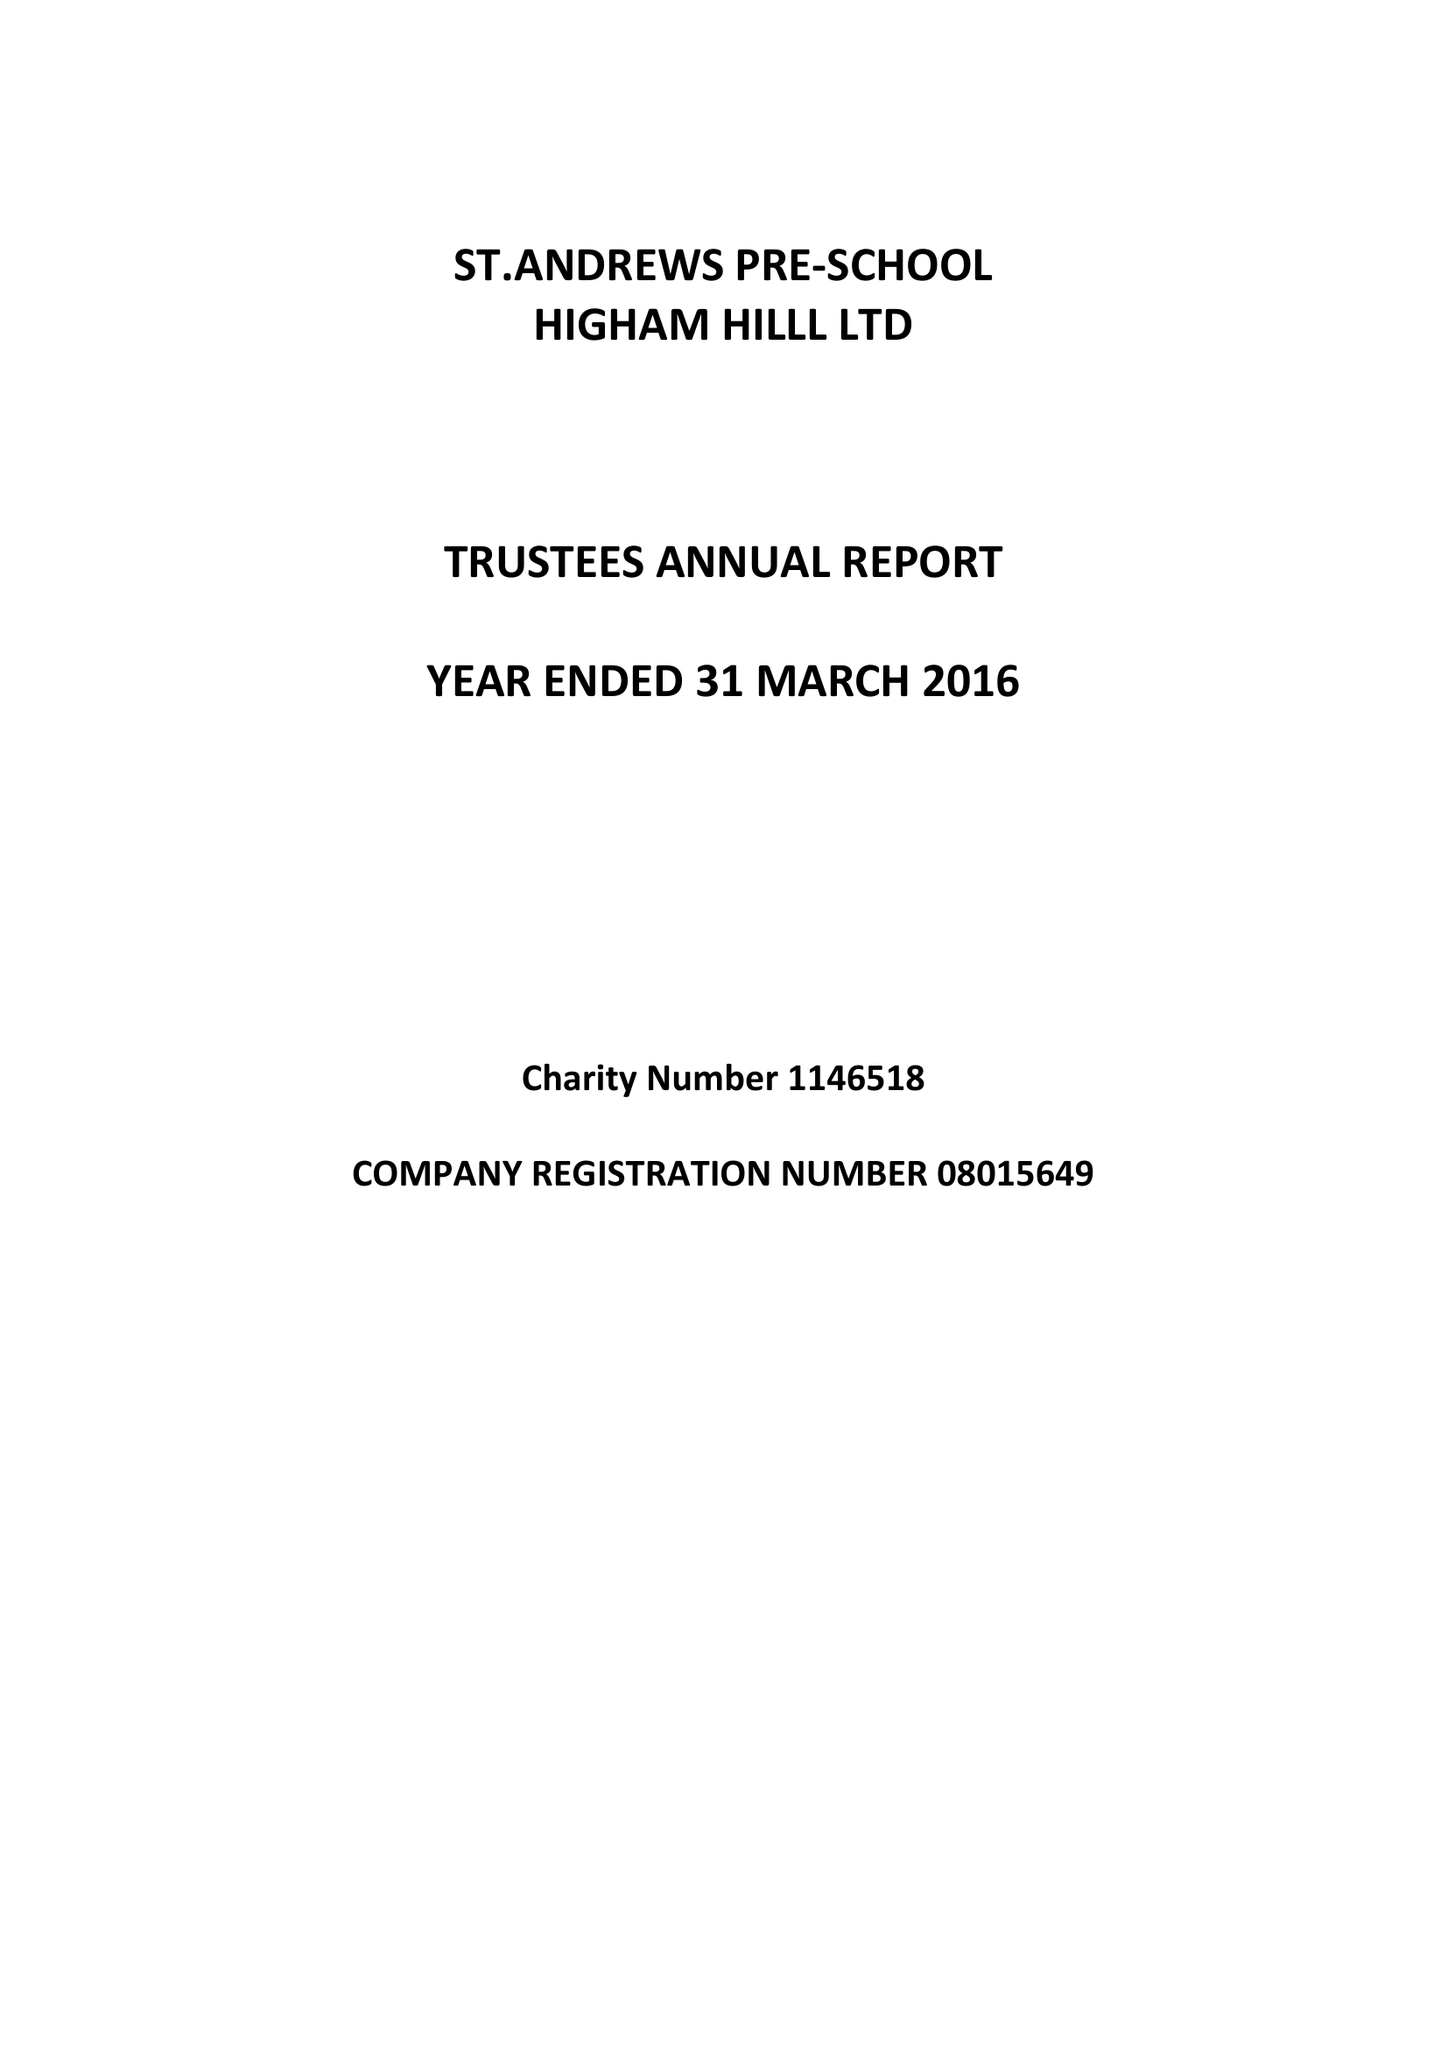What is the value for the address__postcode?
Answer the question using a single word or phrase. E17 6AR 